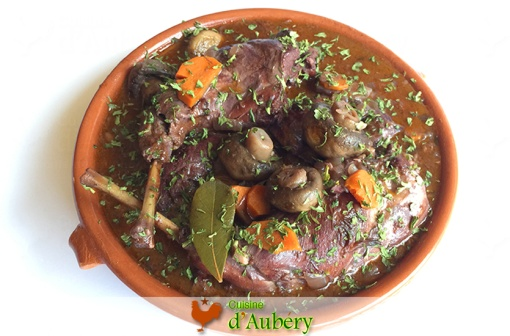Can you tell me a story related to this dish? Once upon a time, in a quaint little village in the heart of France, there lived an old chef named Pierre. He was renowned for his Coq au Vin, a recipe passed down through generations. Every Sunday, the villagers would gather at his humble bistro to savor the rich, flavorful chicken cooked slowly with red wine, mushrooms, carrots, and herbs. The aroma would waft through the cobblestone streets, drawing both locals and tourists alike. Pierre believed that each ingredient told a story, and the bay leaf on top was his signature touch, signifying love and tradition in every bite. 